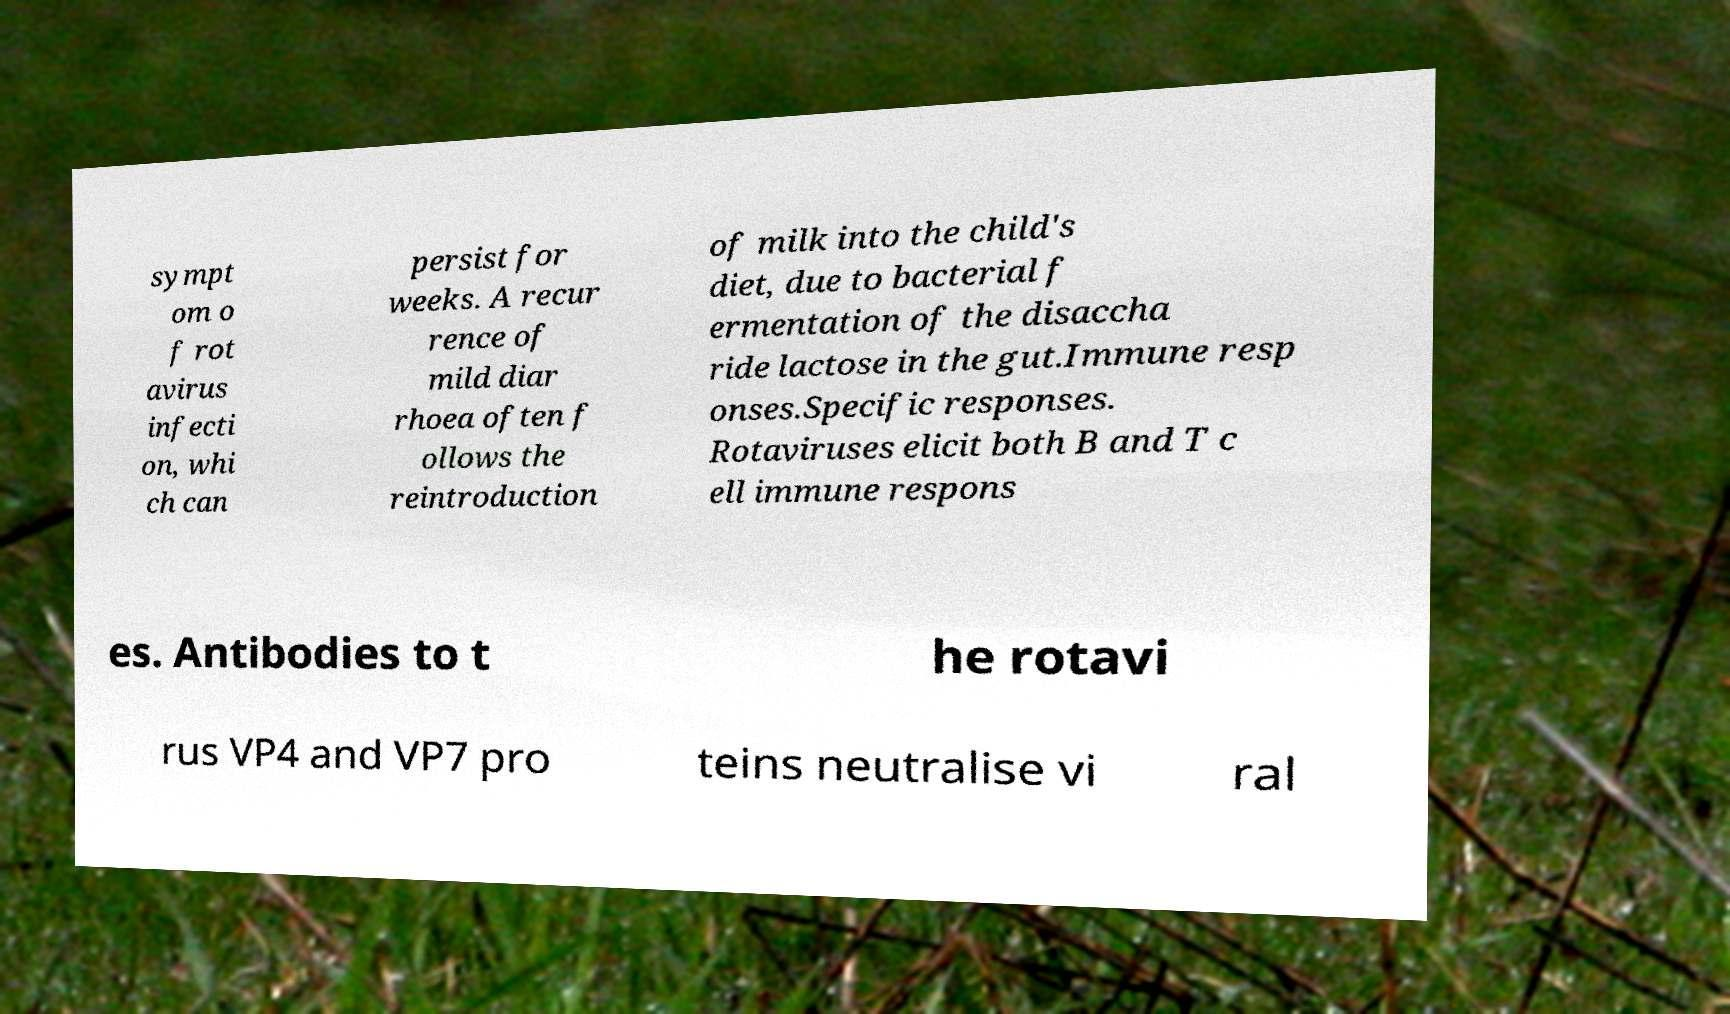What messages or text are displayed in this image? I need them in a readable, typed format. sympt om o f rot avirus infecti on, whi ch can persist for weeks. A recur rence of mild diar rhoea often f ollows the reintroduction of milk into the child's diet, due to bacterial f ermentation of the disaccha ride lactose in the gut.Immune resp onses.Specific responses. Rotaviruses elicit both B and T c ell immune respons es. Antibodies to t he rotavi rus VP4 and VP7 pro teins neutralise vi ral 